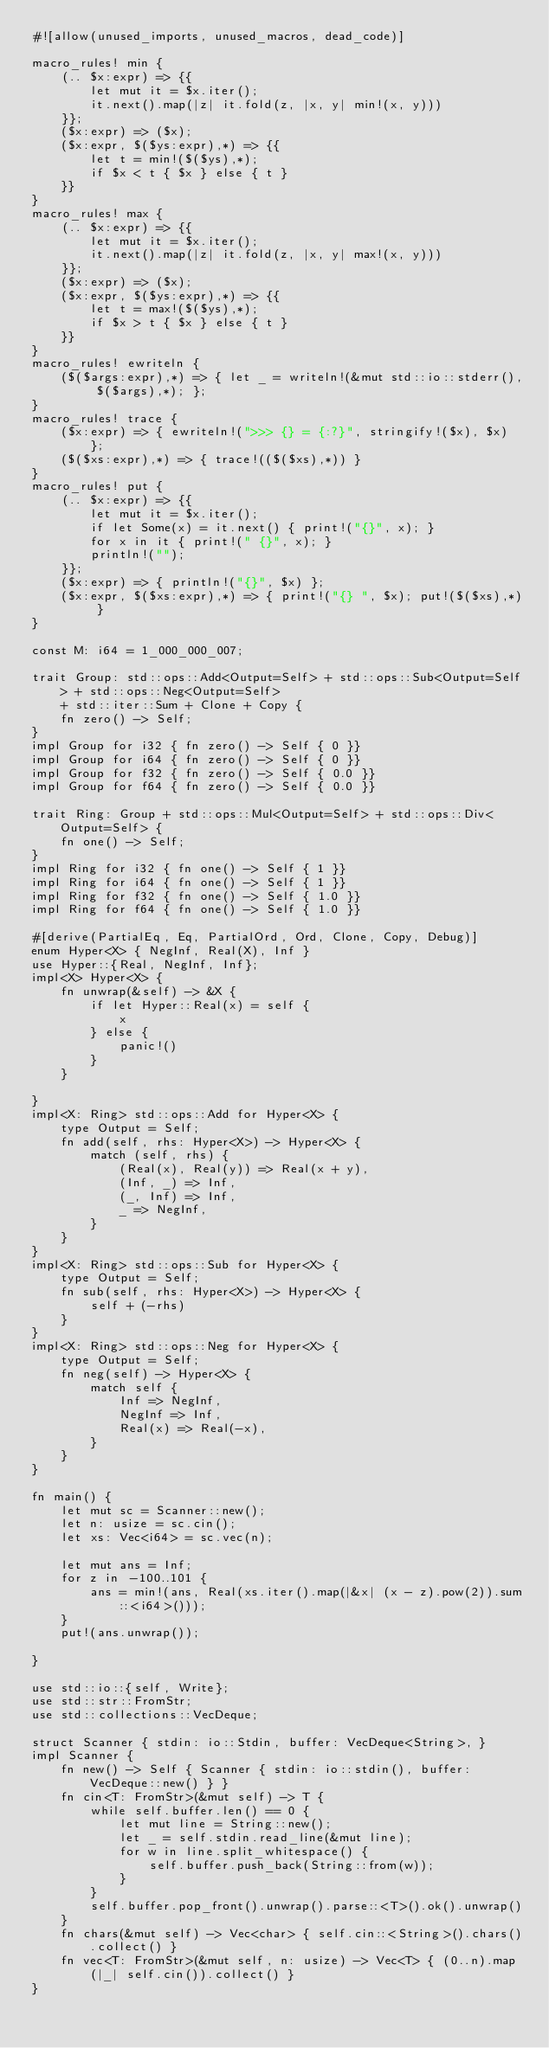<code> <loc_0><loc_0><loc_500><loc_500><_Rust_>#![allow(unused_imports, unused_macros, dead_code)]

macro_rules! min {
    (.. $x:expr) => {{
        let mut it = $x.iter();
        it.next().map(|z| it.fold(z, |x, y| min!(x, y)))
    }};
    ($x:expr) => ($x);
    ($x:expr, $($ys:expr),*) => {{
        let t = min!($($ys),*);
        if $x < t { $x } else { t }
    }}
}
macro_rules! max {
    (.. $x:expr) => {{
        let mut it = $x.iter();
        it.next().map(|z| it.fold(z, |x, y| max!(x, y)))
    }};
    ($x:expr) => ($x);
    ($x:expr, $($ys:expr),*) => {{
        let t = max!($($ys),*);
        if $x > t { $x } else { t }
    }}
}
macro_rules! ewriteln {
    ($($args:expr),*) => { let _ = writeln!(&mut std::io::stderr(), $($args),*); };
}
macro_rules! trace {
    ($x:expr) => { ewriteln!(">>> {} = {:?}", stringify!($x), $x) };
    ($($xs:expr),*) => { trace!(($($xs),*)) }
}
macro_rules! put {
    (.. $x:expr) => {{
        let mut it = $x.iter();
        if let Some(x) = it.next() { print!("{}", x); }
        for x in it { print!(" {}", x); }
        println!("");
    }};
    ($x:expr) => { println!("{}", $x) };
    ($x:expr, $($xs:expr),*) => { print!("{} ", $x); put!($($xs),*) }
}

const M: i64 = 1_000_000_007;

trait Group: std::ops::Add<Output=Self> + std::ops::Sub<Output=Self> + std::ops::Neg<Output=Self>
    + std::iter::Sum + Clone + Copy {
    fn zero() -> Self;
}
impl Group for i32 { fn zero() -> Self { 0 }}
impl Group for i64 { fn zero() -> Self { 0 }}
impl Group for f32 { fn zero() -> Self { 0.0 }}
impl Group for f64 { fn zero() -> Self { 0.0 }}

trait Ring: Group + std::ops::Mul<Output=Self> + std::ops::Div<Output=Self> {
    fn one() -> Self;
}
impl Ring for i32 { fn one() -> Self { 1 }}
impl Ring for i64 { fn one() -> Self { 1 }}
impl Ring for f32 { fn one() -> Self { 1.0 }}
impl Ring for f64 { fn one() -> Self { 1.0 }}

#[derive(PartialEq, Eq, PartialOrd, Ord, Clone, Copy, Debug)]
enum Hyper<X> { NegInf, Real(X), Inf }
use Hyper::{Real, NegInf, Inf};
impl<X> Hyper<X> {
    fn unwrap(&self) -> &X {
        if let Hyper::Real(x) = self {
            x
        } else {
            panic!()
        }
    }

}
impl<X: Ring> std::ops::Add for Hyper<X> {
    type Output = Self;
    fn add(self, rhs: Hyper<X>) -> Hyper<X> {
        match (self, rhs) {
            (Real(x), Real(y)) => Real(x + y),
            (Inf, _) => Inf,
            (_, Inf) => Inf,
            _ => NegInf,
        }
    }
}
impl<X: Ring> std::ops::Sub for Hyper<X> {
    type Output = Self;
    fn sub(self, rhs: Hyper<X>) -> Hyper<X> {
        self + (-rhs)
    }
}
impl<X: Ring> std::ops::Neg for Hyper<X> {
    type Output = Self;
    fn neg(self) -> Hyper<X> {
        match self {
            Inf => NegInf,
            NegInf => Inf,
            Real(x) => Real(-x),
        }
    }
}

fn main() {
    let mut sc = Scanner::new();
    let n: usize = sc.cin();
    let xs: Vec<i64> = sc.vec(n);

    let mut ans = Inf;
    for z in -100..101 {
        ans = min!(ans, Real(xs.iter().map(|&x| (x - z).pow(2)).sum::<i64>()));
    }
    put!(ans.unwrap());

}

use std::io::{self, Write};
use std::str::FromStr;
use std::collections::VecDeque;

struct Scanner { stdin: io::Stdin, buffer: VecDeque<String>, }
impl Scanner {
    fn new() -> Self { Scanner { stdin: io::stdin(), buffer: VecDeque::new() } }
    fn cin<T: FromStr>(&mut self) -> T {
        while self.buffer.len() == 0 {
            let mut line = String::new();
            let _ = self.stdin.read_line(&mut line);
            for w in line.split_whitespace() {
                self.buffer.push_back(String::from(w));
            }
        }
        self.buffer.pop_front().unwrap().parse::<T>().ok().unwrap()
    }
    fn chars(&mut self) -> Vec<char> { self.cin::<String>().chars().collect() }
    fn vec<T: FromStr>(&mut self, n: usize) -> Vec<T> { (0..n).map(|_| self.cin()).collect() }
}
</code> 